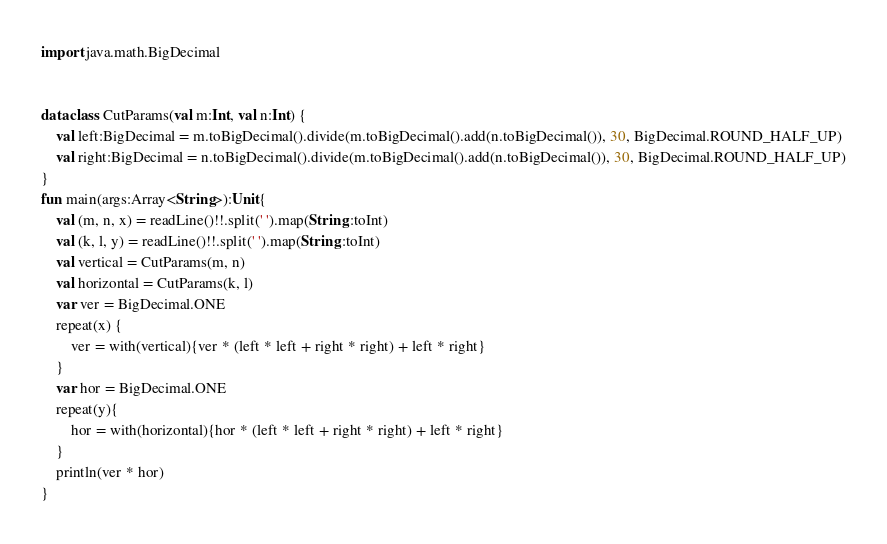Convert code to text. <code><loc_0><loc_0><loc_500><loc_500><_Kotlin_>
import java.math.BigDecimal


data class CutParams(val m:Int, val n:Int) {
    val left:BigDecimal = m.toBigDecimal().divide(m.toBigDecimal().add(n.toBigDecimal()), 30, BigDecimal.ROUND_HALF_UP)
    val right:BigDecimal = n.toBigDecimal().divide(m.toBigDecimal().add(n.toBigDecimal()), 30, BigDecimal.ROUND_HALF_UP)
}
fun main(args:Array<String>):Unit{
    val (m, n, x) = readLine()!!.split(' ').map(String::toInt)
    val (k, l, y) = readLine()!!.split(' ').map(String::toInt)
    val vertical = CutParams(m, n)
    val horizontal = CutParams(k, l)
    var ver = BigDecimal.ONE
    repeat(x) {
        ver = with(vertical){ver * (left * left + right * right) + left * right}
    }
    var hor = BigDecimal.ONE
    repeat(y){
        hor = with(horizontal){hor * (left * left + right * right) + left * right}
    }
    println(ver * hor)
}
</code> 